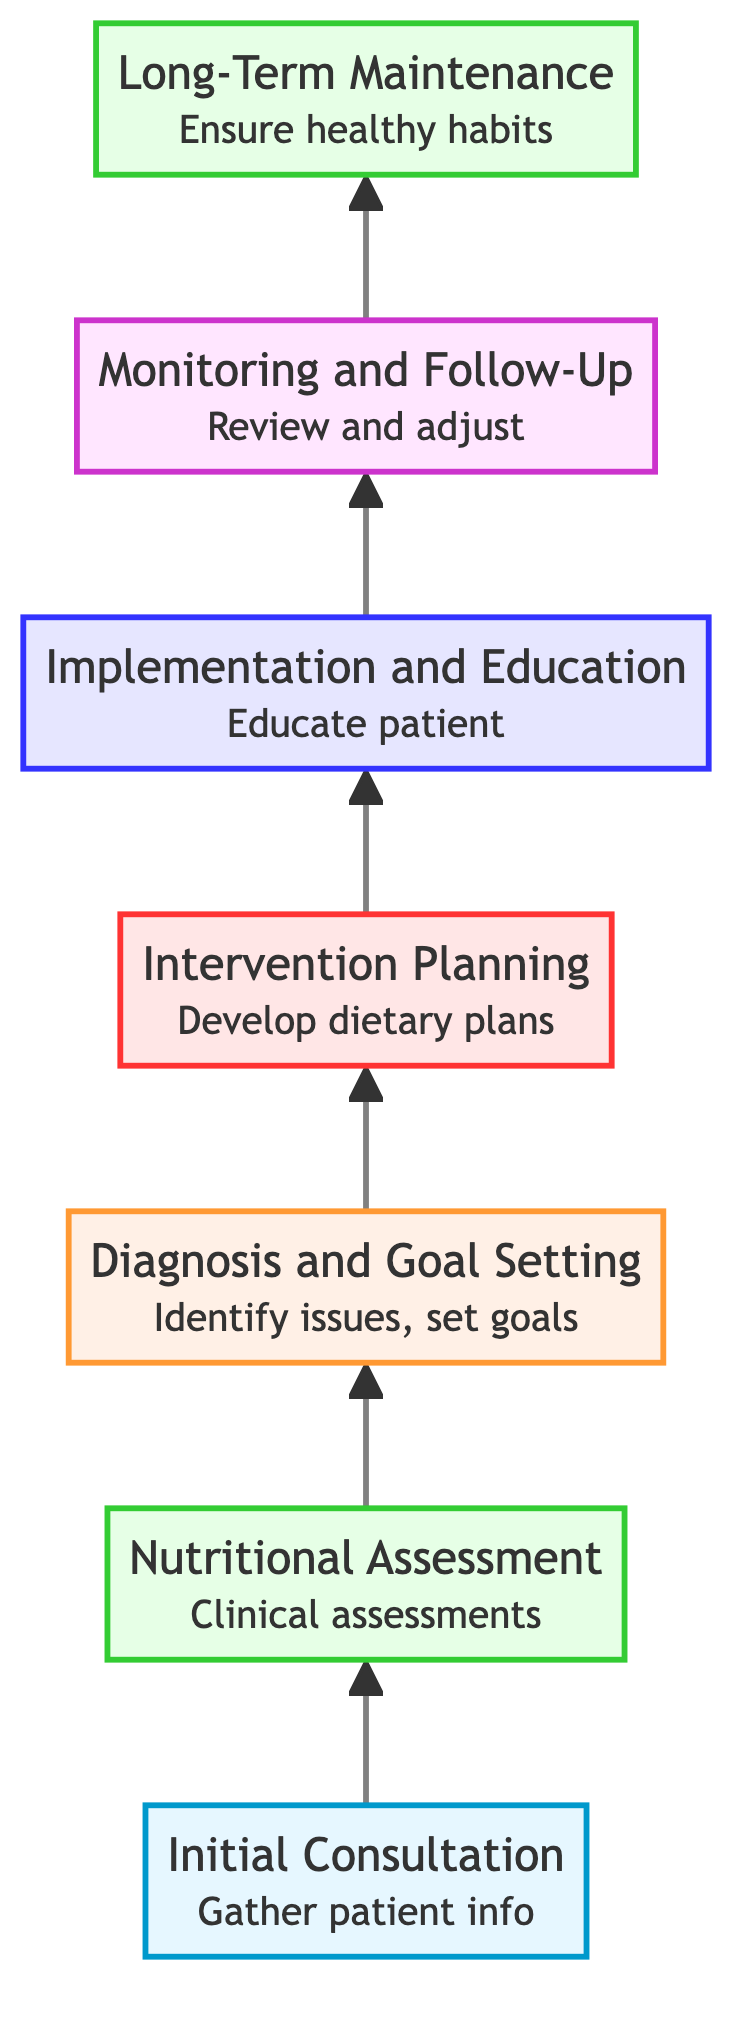What is the first step in the individual dietary plan development? The diagram shows "Initial Consultation" at the bottom, indicating it's the first step in the process.
Answer: Initial Consultation How many levels are in the diagram? The diagram presents seven distinct levels, with each step representing a different level.
Answer: 7 What is the title of the level just above 'Nutritional Assessment'? 'Diagnosis and Goal Setting' is listed directly above 'Nutritional Assessment', making it the subsequent step in the flow.
Answer: Diagnosis and Goal Setting What is the last step in the dietary plan development process? The topmost node in the flowchart is 'Long-Term Maintenance', which signifies the final step in the process.
Answer: Long-Term Maintenance What type of activities are included in the 'Implementation and Education' phase? This step encompasses activities like "Patient education sessions", "Cooking demonstrations", and "Grocery shopping guides", focusing on educating the patient regarding their dietary plan.
Answer: Educate patient What follows 'Intervention Planning' in the chart? The chart indicates that 'Implementation and Education' follows 'Intervention Planning', showing the flow of the process.
Answer: Implementation and Education How does 'Nutritional Assessment' relate to 'Initial Consultation'? 'Nutritional Assessment' directly follows 'Initial Consultation' in the flow, indicating it is the next necessary step after gathering initial patient information.
Answer: Next step During which step is the dietary plan primarily developed? 'Intervention Planning' is identified as the step where individualized dietary plans are primarily developed, based on previous assessments and goals.
Answer: Intervention Planning What is required before 'Monitoring and Follow-Up'? The step 'Implementation and Education' occurs before 'Monitoring and Follow-Up', emphasizing the need to educate the patient on the dietary plan components first.
Answer: Implementation and Education 